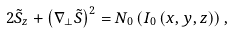Convert formula to latex. <formula><loc_0><loc_0><loc_500><loc_500>2 \tilde { S } _ { z } + \left ( \nabla _ { \bot } \tilde { S } \right ) ^ { 2 } = N _ { 0 } \left ( I _ { 0 } \left ( x , y , z \right ) \right ) ,</formula> 